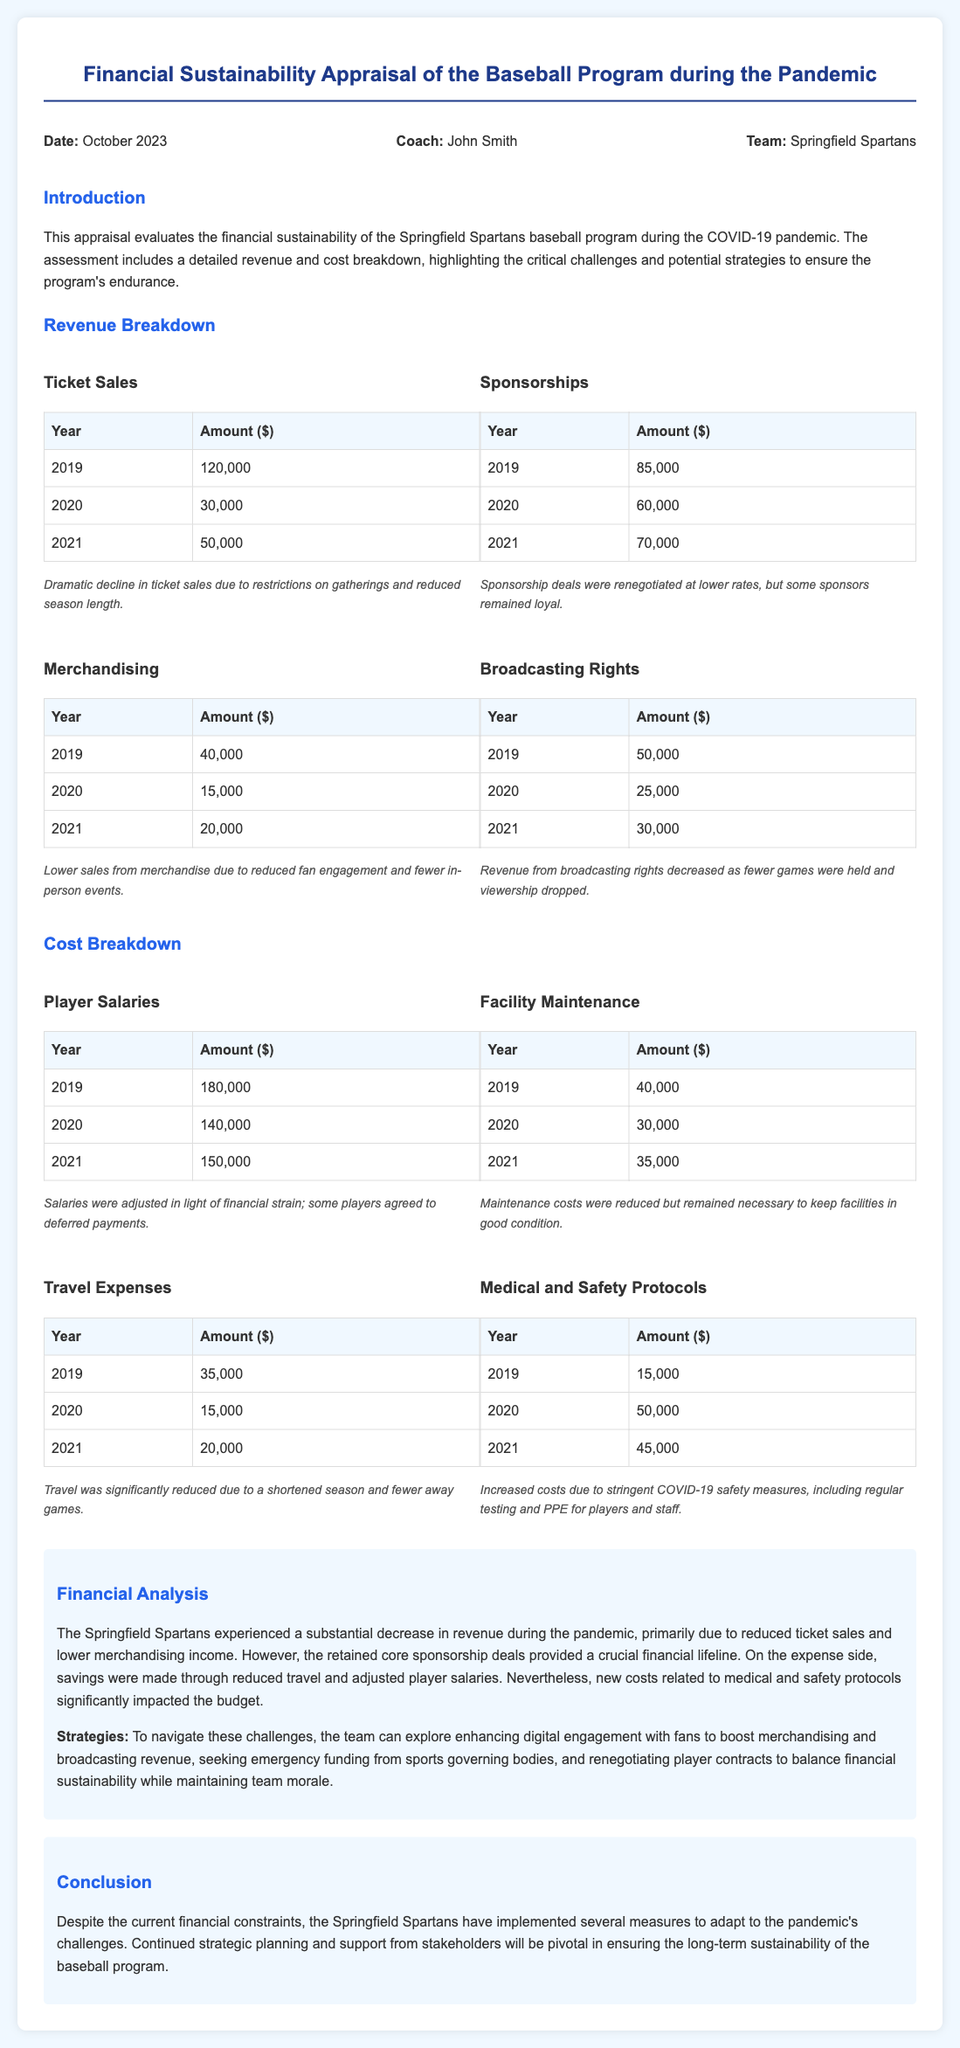What is the total revenue from Ticket Sales in 2021? The total revenue from Ticket Sales in 2021 is directly mentioned in the document.
Answer: 50000 What is the total amount spent on Player Salaries in 2020? The total amount spent on Player Salaries in 2020 can be found in the breakdown table for that category.
Answer: 140000 What year did the Springfield Spartans have the highest revenue from Sponsorships? The year with the highest revenue from Sponsorships can be identified in the table for Sponsorships.
Answer: 2019 How much did the team spend on Medical and Safety Protocols in 2020? This expense is clearly outlined in the cost breakdown section for Medical and Safety Protocols.
Answer: 50000 What was the decline in Ticket Sales from 2019 to 2020? To find this, subtract 2020 Ticket Sales from 2019 Ticket Sales as presented in the document.
Answer: 90000 What key strategy can enhance revenue according to the financial analysis? The financial analysis section discusses strategies and mentions enhancing digital engagement with fans.
Answer: Digital engagement What was the total revenue from Broadcasting Rights in 2021? The total revenue from Broadcasting Rights in 2021 is listed in the corresponding breakdown table.
Answer: 30000 What conclusion is drawn about the financial sustainability of the program? The conclusion section summarizes findings based on the financial appraisal, indicating ongoing challenges.
Answer: Long-term sustainability Which cost category increased significantly due to the pandemic? The cost breakdown provides insights into cost categories, identifying which increased due to new measures.
Answer: Medical and Safety Protocols 